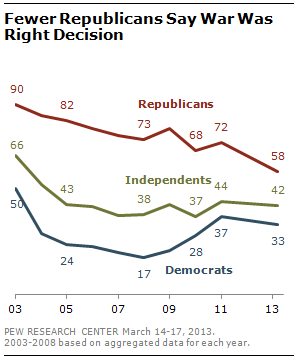Outline some significant characteristics in this image. The average of all green data points above 40 is 48.75. The value of the blue line is always less than the other two lines. 